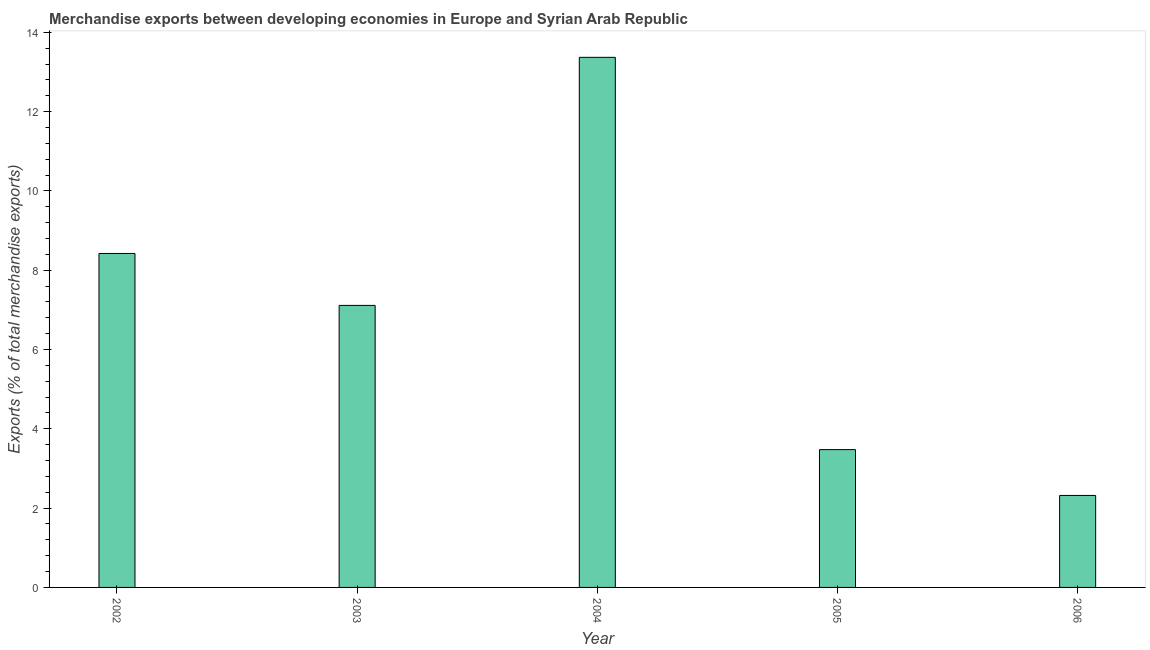What is the title of the graph?
Make the answer very short. Merchandise exports between developing economies in Europe and Syrian Arab Republic. What is the label or title of the X-axis?
Offer a terse response. Year. What is the label or title of the Y-axis?
Provide a short and direct response. Exports (% of total merchandise exports). What is the merchandise exports in 2003?
Your response must be concise. 7.11. Across all years, what is the maximum merchandise exports?
Give a very brief answer. 13.37. Across all years, what is the minimum merchandise exports?
Make the answer very short. 2.32. What is the sum of the merchandise exports?
Provide a short and direct response. 34.7. What is the difference between the merchandise exports in 2002 and 2005?
Make the answer very short. 4.95. What is the average merchandise exports per year?
Your answer should be very brief. 6.94. What is the median merchandise exports?
Provide a succinct answer. 7.11. Do a majority of the years between 2006 and 2005 (inclusive) have merchandise exports greater than 6 %?
Give a very brief answer. No. What is the ratio of the merchandise exports in 2004 to that in 2006?
Your answer should be very brief. 5.76. Is the merchandise exports in 2003 less than that in 2004?
Ensure brevity in your answer.  Yes. Is the difference between the merchandise exports in 2003 and 2004 greater than the difference between any two years?
Make the answer very short. No. What is the difference between the highest and the second highest merchandise exports?
Give a very brief answer. 4.95. Is the sum of the merchandise exports in 2002 and 2006 greater than the maximum merchandise exports across all years?
Provide a succinct answer. No. What is the difference between the highest and the lowest merchandise exports?
Your answer should be compact. 11.05. How many bars are there?
Give a very brief answer. 5. How many years are there in the graph?
Your answer should be very brief. 5. What is the Exports (% of total merchandise exports) of 2002?
Your answer should be very brief. 8.42. What is the Exports (% of total merchandise exports) of 2003?
Make the answer very short. 7.11. What is the Exports (% of total merchandise exports) in 2004?
Ensure brevity in your answer.  13.37. What is the Exports (% of total merchandise exports) of 2005?
Your answer should be very brief. 3.48. What is the Exports (% of total merchandise exports) in 2006?
Ensure brevity in your answer.  2.32. What is the difference between the Exports (% of total merchandise exports) in 2002 and 2003?
Make the answer very short. 1.31. What is the difference between the Exports (% of total merchandise exports) in 2002 and 2004?
Provide a short and direct response. -4.95. What is the difference between the Exports (% of total merchandise exports) in 2002 and 2005?
Your answer should be very brief. 4.95. What is the difference between the Exports (% of total merchandise exports) in 2002 and 2006?
Your answer should be very brief. 6.1. What is the difference between the Exports (% of total merchandise exports) in 2003 and 2004?
Your response must be concise. -6.26. What is the difference between the Exports (% of total merchandise exports) in 2003 and 2005?
Your answer should be very brief. 3.64. What is the difference between the Exports (% of total merchandise exports) in 2003 and 2006?
Make the answer very short. 4.79. What is the difference between the Exports (% of total merchandise exports) in 2004 and 2005?
Your answer should be compact. 9.89. What is the difference between the Exports (% of total merchandise exports) in 2004 and 2006?
Ensure brevity in your answer.  11.05. What is the difference between the Exports (% of total merchandise exports) in 2005 and 2006?
Provide a succinct answer. 1.16. What is the ratio of the Exports (% of total merchandise exports) in 2002 to that in 2003?
Offer a very short reply. 1.18. What is the ratio of the Exports (% of total merchandise exports) in 2002 to that in 2004?
Provide a succinct answer. 0.63. What is the ratio of the Exports (% of total merchandise exports) in 2002 to that in 2005?
Provide a succinct answer. 2.42. What is the ratio of the Exports (% of total merchandise exports) in 2002 to that in 2006?
Make the answer very short. 3.63. What is the ratio of the Exports (% of total merchandise exports) in 2003 to that in 2004?
Ensure brevity in your answer.  0.53. What is the ratio of the Exports (% of total merchandise exports) in 2003 to that in 2005?
Your answer should be very brief. 2.05. What is the ratio of the Exports (% of total merchandise exports) in 2003 to that in 2006?
Give a very brief answer. 3.07. What is the ratio of the Exports (% of total merchandise exports) in 2004 to that in 2005?
Offer a terse response. 3.85. What is the ratio of the Exports (% of total merchandise exports) in 2004 to that in 2006?
Your response must be concise. 5.76. What is the ratio of the Exports (% of total merchandise exports) in 2005 to that in 2006?
Your answer should be very brief. 1.5. 